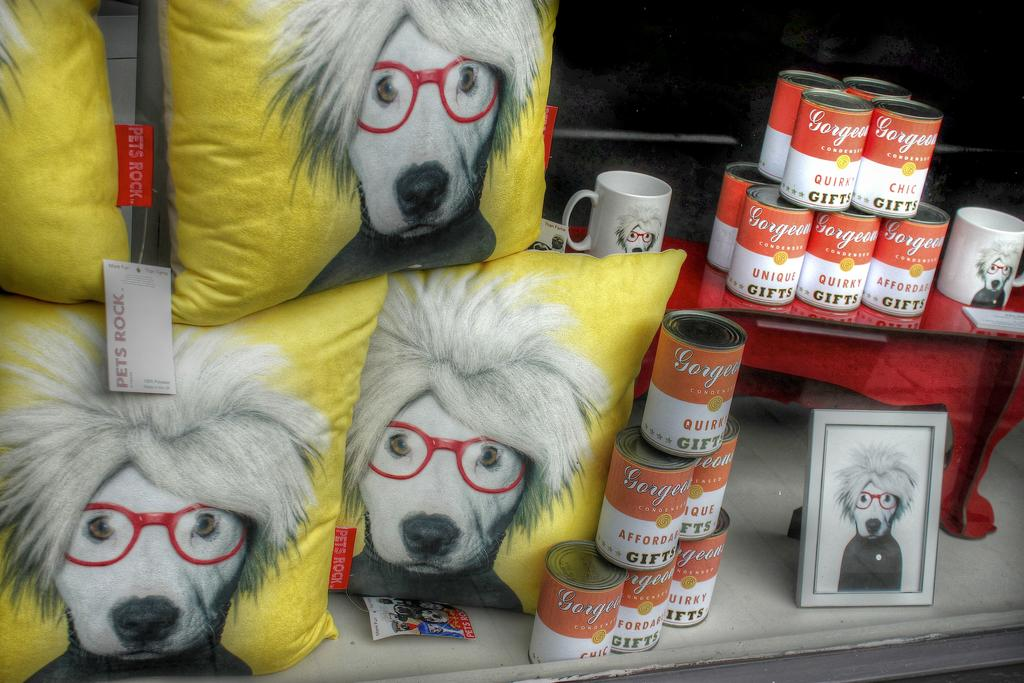What type of furniture is present in the image? There is a table in the image. What objects are placed on the table? There are tins, mugs, pillows, and a frame on the table. Can you describe the objects on the table in more detail? The tins are likely for storage or decoration, the mugs could be for holding beverages, the pillows might be for comfort or decoration, and the frame could be for displaying a photo or artwork. What type of sea creature can be seen swimming in the image? There is no sea creature present in the image; it features a table with various objects on it. 